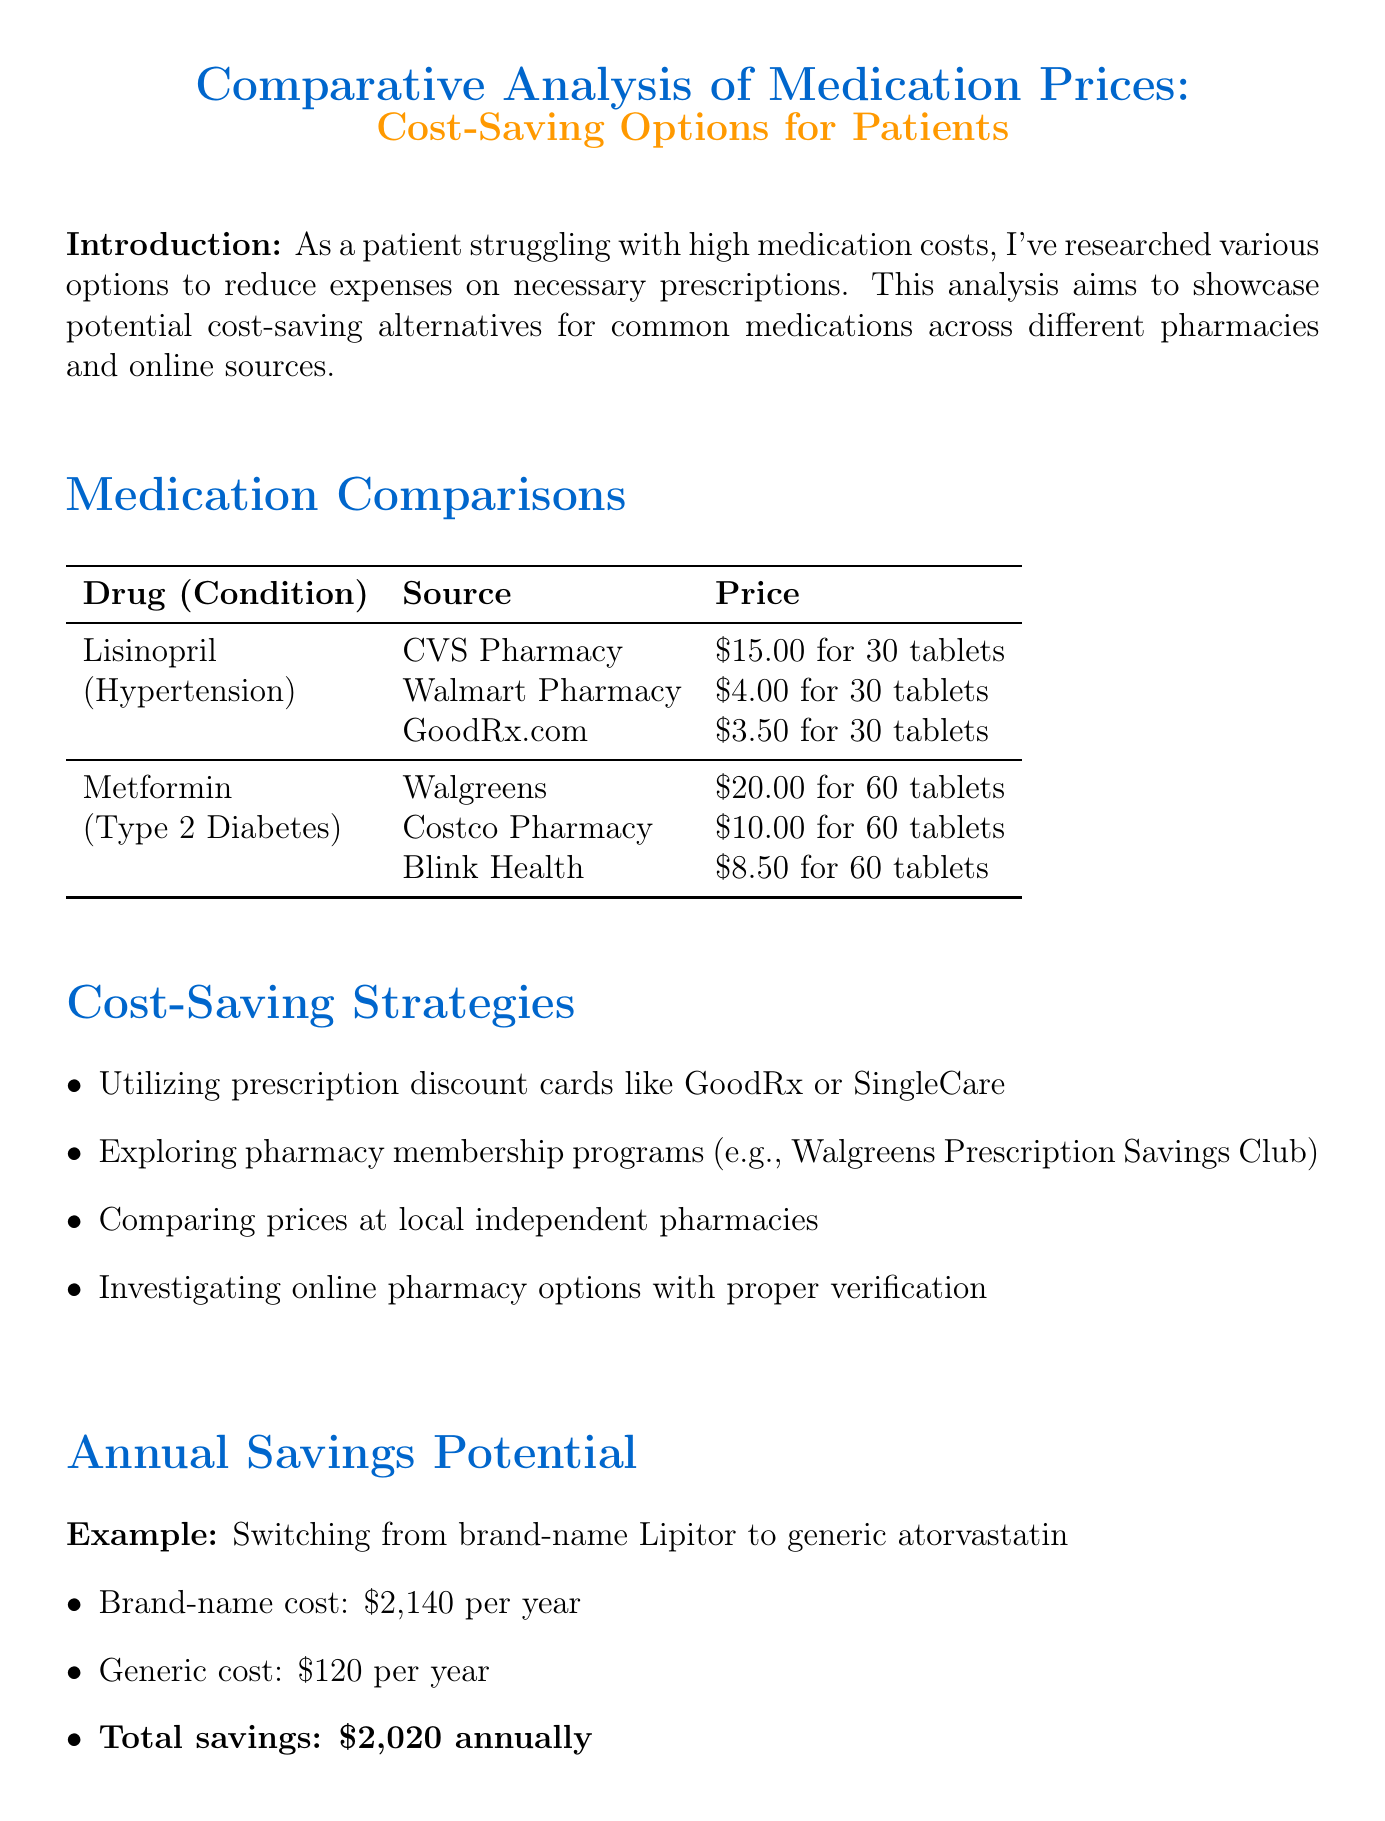what is the drug name for hypertension? The document lists Lisinopril as the medication for hypertension.
Answer: Lisinopril how much does GoodRx.com charge for Lisinopril? GoodRx.com lists the price for Lisinopril at $3.50 for 30 tablets.
Answer: $3.50 which pharmacy offers the lowest price for Metformin? The document indicates that Blink Health provides the lowest price for Metformin at $8.50.
Answer: Blink Health what is the potential annual savings from switching to generic atorvastatin? The annual savings potential from switching to generic atorvastatin is specified in the document.
Answer: $2,020 name one cost-saving strategy mentioned in the report. The report provides various cost-saving strategies that suggest options to reduce medication costs.
Answer: Utilizing prescription discount cards how many tablets of Metformin does Walgreens supply? The document states that Walgreens supplies 60 tablets of Metformin.
Answer: 60 tablets what is the condition treated by Lisinopril? The document associates Lisinopril with a specific medical condition.
Answer: Hypertension what is the purpose of this analysis? The document clearly defines the objective of the analysis right after the introduction section.
Answer: Showcase potential cost-saving alternatives 